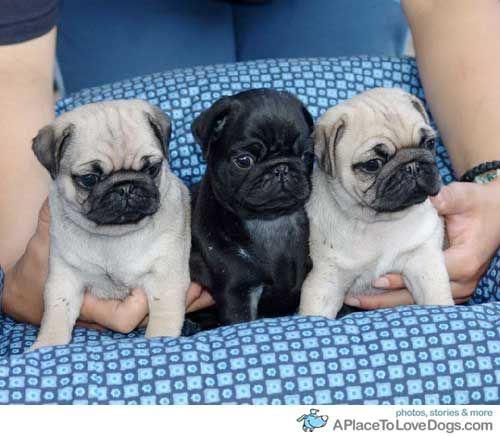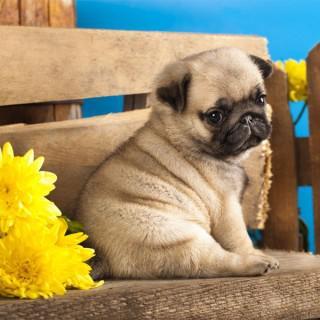The first image is the image on the left, the second image is the image on the right. Given the left and right images, does the statement "There is at least one pug dog in the center of both images." hold true? Answer yes or no. No. The first image is the image on the left, the second image is the image on the right. Assess this claim about the two images: "Each image contains a trio of pugs and includes at least two beige pugs with dark muzzles.". Correct or not? Answer yes or no. No. 